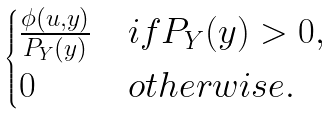Convert formula to latex. <formula><loc_0><loc_0><loc_500><loc_500>\begin{cases} \frac { \phi ( u , y ) } { P _ { Y } ( y ) } & i f P _ { Y } ( y ) > 0 , \\ 0 & o t h e r w i s e . \end{cases}</formula> 